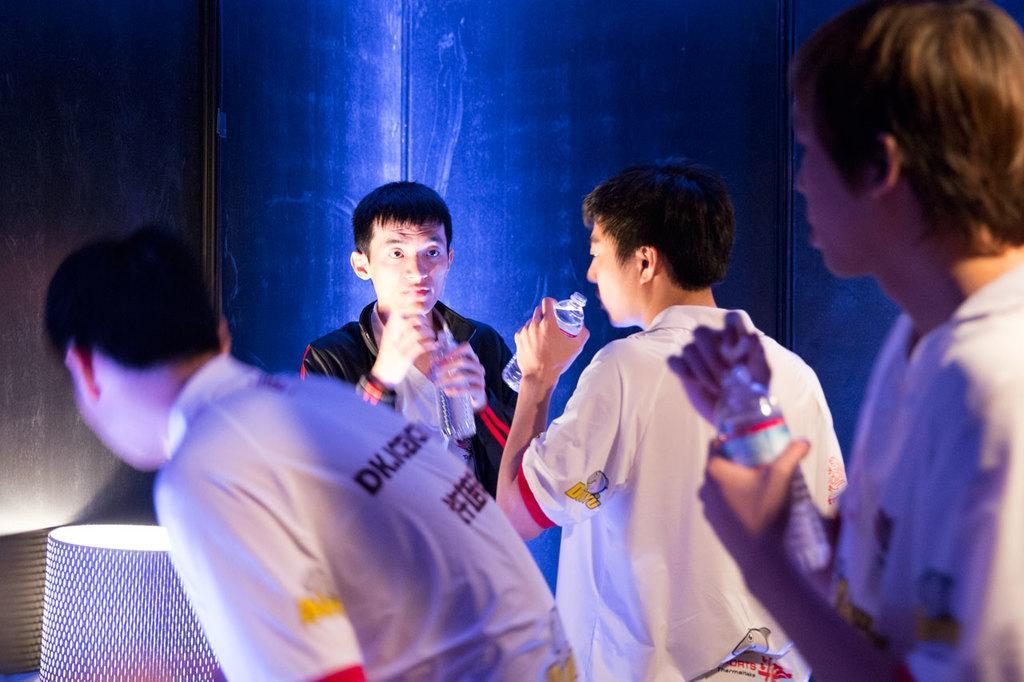How many people are present in the image? There are four persons in the image. What are some of the people holding in the image? Three of the persons are holding water bottles. What can be seen in the background of the image? There is a lamp and other objects in the background of the image. What type of knot is being tied by the person in the image? There is no person tying a knot in the image. Can you describe the stamp on the person's feet in the image? There are no stamps or feet visible in the image. 